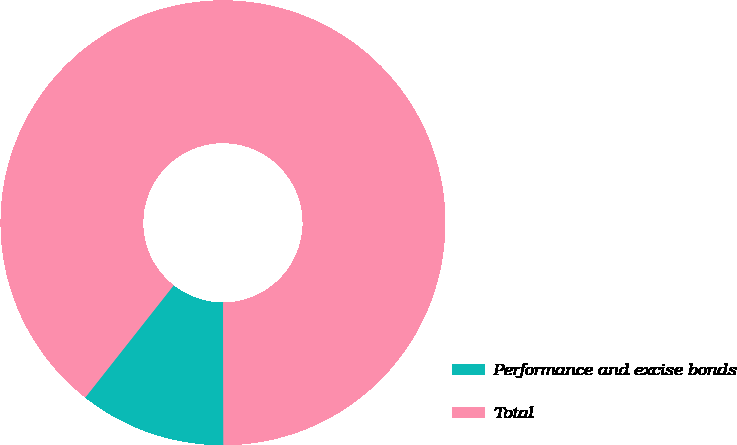<chart> <loc_0><loc_0><loc_500><loc_500><pie_chart><fcel>Performance and excise bonds<fcel>Total<nl><fcel>10.66%<fcel>89.34%<nl></chart> 